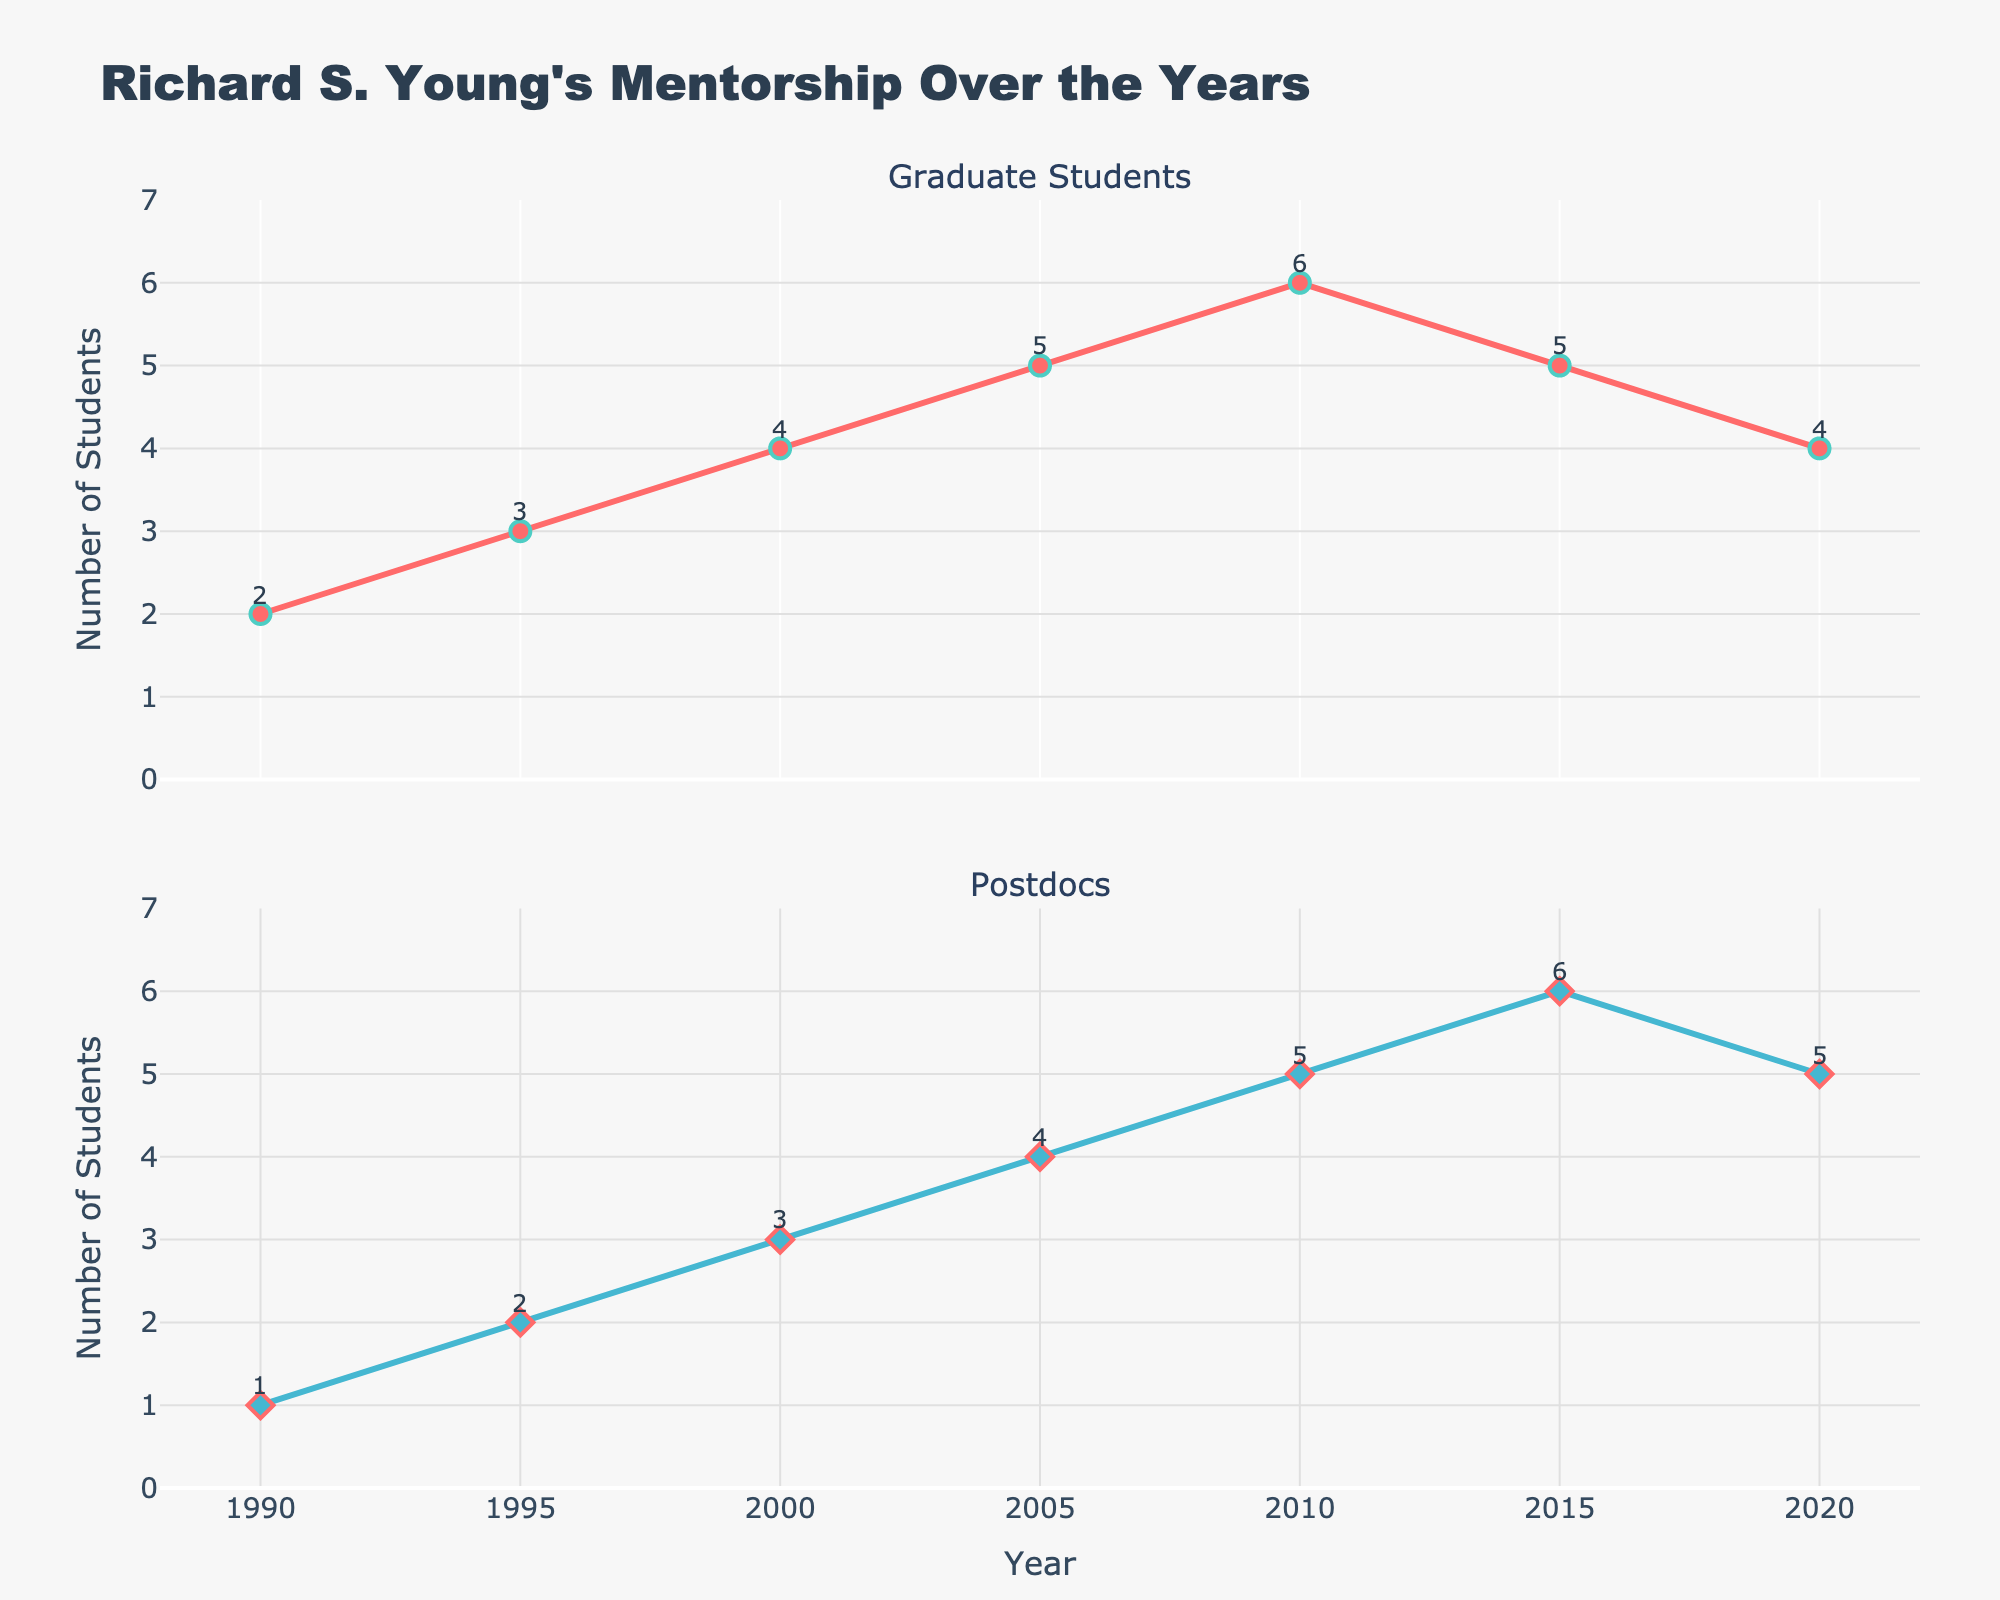How many graduate students were mentored in 2010? Look at the "Graduate Students" subplot and find the data point for the year 2010. The value shown is 6.
Answer: 6 What is the difference between the number of graduate students and postdocs mentored in 2000? In the year 2000, the number of graduate students was 4 and the number of postdocs was 3. The difference is 4 - 3 = 1.
Answer: 1 In which year did Richard mentor the highest number of postdocs? Look at the "Postdocs" subplot and identify the highest data point. The peak value of 6 is in the year 2015.
Answer: 2015 How did the number of graduate students mentored change from 1990 to 2005? In 1990, 2 graduate students were mentored, and in 2005, this number increased to 5. The increase is 5 - 2 = 3.
Answer: Increased by 3 How many postdocs in total were mentored from 1990 to 2020? Add up the number of postdocs mentored each year: 1 (1990) + 2 (1995) + 3 (2000) + 4 (2005) + 5 (2010) + 6 (2015) + 5 (2020) = 26.
Answer: 26 Which type of mentorship showed a decrease between 2015 and 2020? For graduate students, the number dropped from 5 in 2015 to 4 in 2020. For postdocs, the number decreased from 6 to 5. Both types showed a decrease.
Answer: Both What is the trend in the number of graduate students mentored from 1990 to 2010? From 1990 (2 students) to 2010 (6 students), there is a general upward trend, except for a slight decrease after 2015.
Answer: Upward trend Which year had an equal number of graduate students and postdocs mentored? Check both subplots and look for a year where both values are the same. There is no year where an equal number is mentored.
Answer: None How many years did the number of graduate students mentored stay the same compared to the previous year? By checking the "Graduate Students" subplot, we see the numbers are different each year except for 2010 to 2015, where it stayed at 5.
Answer: 1 year 